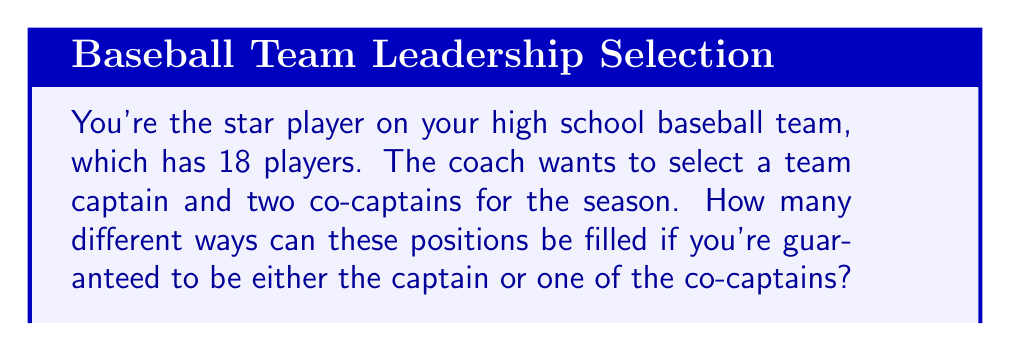Teach me how to tackle this problem. Let's approach this step-by-step:

1) First, consider the case where you are the captain:
   - You are already selected as captain
   - The coach needs to choose 2 co-captains from the remaining 17 players
   - This is a combination problem: $\binom{17}{2}$

2) Now, consider the case where you are one of the co-captains:
   - The coach needs to choose 1 captain from the other 17 players
   - You are already selected as one co-captain
   - The coach needs to choose 1 more co-captain from the remaining 16 players
   - This is a product of two choices: $17 \times 16$

3) Add these two cases together:

   $$\binom{17}{2} + 17 \times 16$$

4) Calculate:
   $$\binom{17}{2} = \frac{17!}{2!(17-2)!} = \frac{17 \times 16}{2} = 136$$
   $$17 \times 16 = 272$$

5) Sum the results:
   $$136 + 272 = 408$$

Therefore, there are 408 different ways to select the captain and co-captains with you in one of these positions.
Answer: 408 